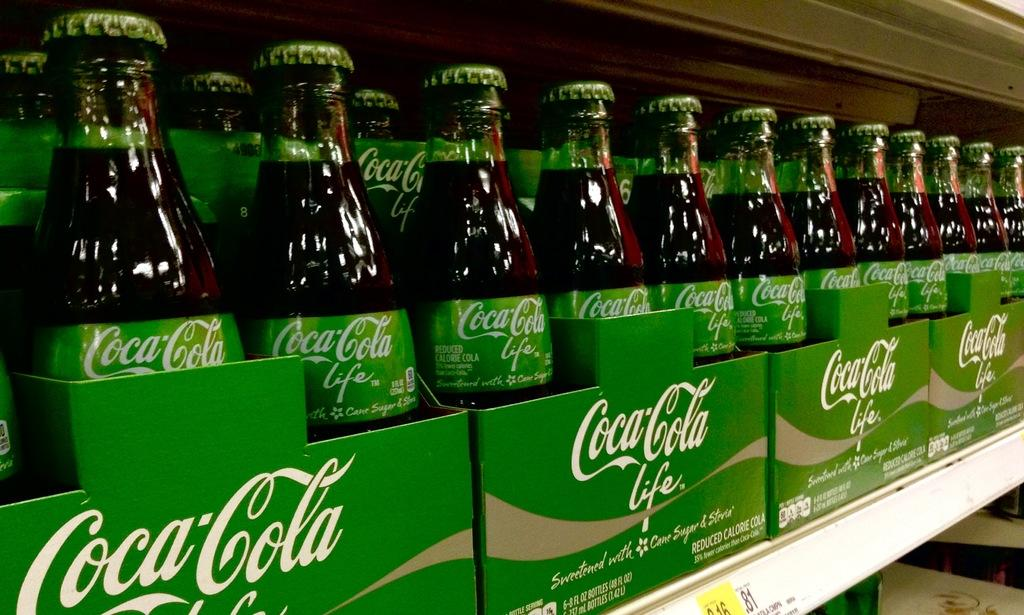What type of containers are visible in the image? There are glass bottles in the image. How are the glass bottles arranged or organized? The glass bottles are placed in green cartons. What is written on the cartons? The text "Coca Cola Life" is written on the cartons. How many stamps are on the glass bottles in the image? There are no stamps visible on the glass bottles in the image. What type of vegetable is growing out of the cartons in the image? There are no vegetables, such as yams, present in the image. 